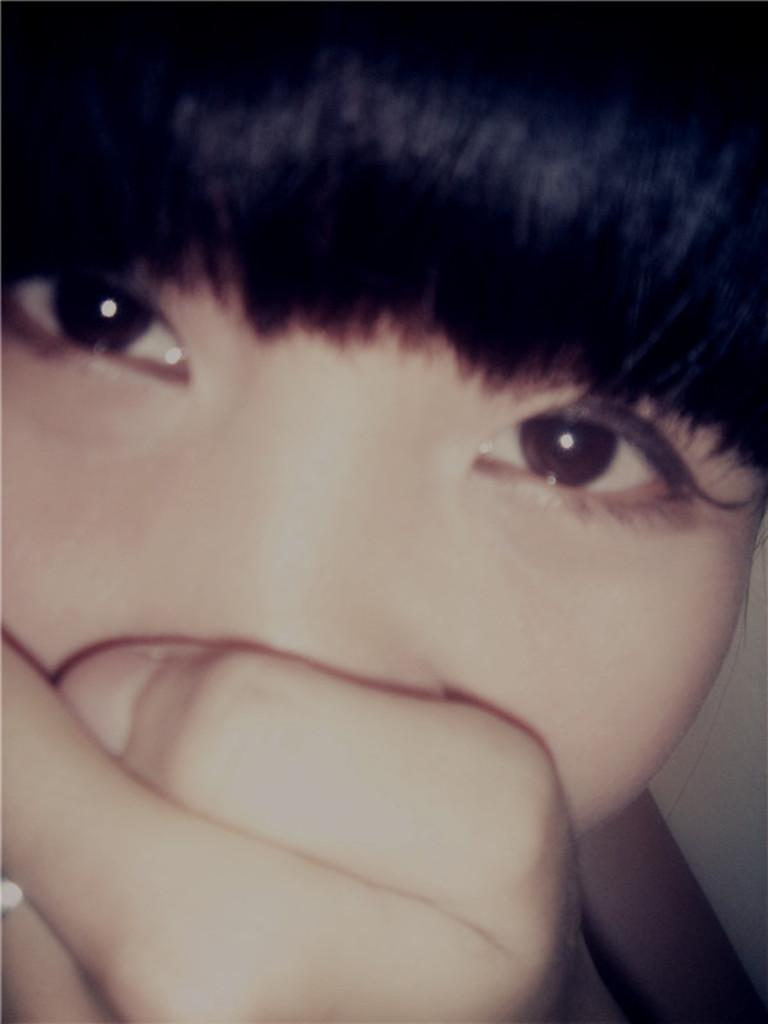What is the main subject of the image? There is a person in the image. What is the person doing in the image? The person is putting their hand on their face. What type of nail can be seen in the image? There is no nail present in the image; it features a person putting their hand on their face. What is the slope of the things in the image? There are no things or slope mentioned in the image, as it only features a person putting their hand on their face. 